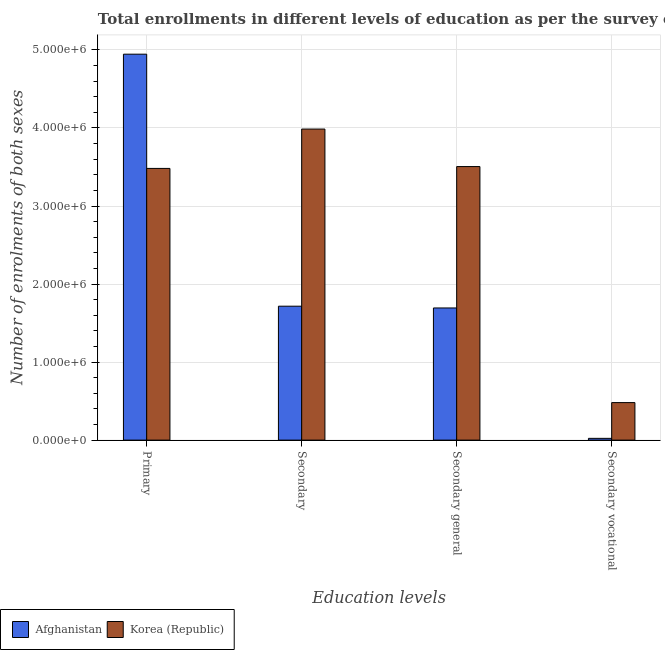How many groups of bars are there?
Offer a very short reply. 4. Are the number of bars per tick equal to the number of legend labels?
Your response must be concise. Yes. How many bars are there on the 4th tick from the left?
Make the answer very short. 2. What is the label of the 2nd group of bars from the left?
Provide a short and direct response. Secondary. What is the number of enrolments in secondary vocational education in Korea (Republic)?
Your answer should be very brief. 4.81e+05. Across all countries, what is the maximum number of enrolments in secondary vocational education?
Ensure brevity in your answer.  4.81e+05. Across all countries, what is the minimum number of enrolments in secondary vocational education?
Keep it short and to the point. 2.27e+04. In which country was the number of enrolments in secondary vocational education minimum?
Provide a short and direct response. Afghanistan. What is the total number of enrolments in secondary general education in the graph?
Ensure brevity in your answer.  5.20e+06. What is the difference between the number of enrolments in secondary education in Korea (Republic) and that in Afghanistan?
Make the answer very short. 2.27e+06. What is the difference between the number of enrolments in secondary general education in Korea (Republic) and the number of enrolments in primary education in Afghanistan?
Give a very brief answer. -1.44e+06. What is the average number of enrolments in primary education per country?
Your answer should be very brief. 4.21e+06. What is the difference between the number of enrolments in primary education and number of enrolments in secondary general education in Korea (Republic)?
Ensure brevity in your answer.  -2.35e+04. What is the ratio of the number of enrolments in secondary education in Korea (Republic) to that in Afghanistan?
Provide a short and direct response. 2.32. Is the number of enrolments in secondary education in Afghanistan less than that in Korea (Republic)?
Your response must be concise. Yes. What is the difference between the highest and the second highest number of enrolments in secondary education?
Provide a succinct answer. 2.27e+06. What is the difference between the highest and the lowest number of enrolments in secondary education?
Your response must be concise. 2.27e+06. What does the 2nd bar from the left in Primary represents?
Make the answer very short. Korea (Republic). Is it the case that in every country, the sum of the number of enrolments in primary education and number of enrolments in secondary education is greater than the number of enrolments in secondary general education?
Make the answer very short. Yes. How many bars are there?
Provide a short and direct response. 8. How many countries are there in the graph?
Your response must be concise. 2. Are the values on the major ticks of Y-axis written in scientific E-notation?
Keep it short and to the point. Yes. What is the title of the graph?
Your answer should be compact. Total enrollments in different levels of education as per the survey of 2009. What is the label or title of the X-axis?
Keep it short and to the point. Education levels. What is the label or title of the Y-axis?
Keep it short and to the point. Number of enrolments of both sexes. What is the Number of enrolments of both sexes of Afghanistan in Primary?
Your answer should be very brief. 4.95e+06. What is the Number of enrolments of both sexes of Korea (Republic) in Primary?
Your answer should be very brief. 3.48e+06. What is the Number of enrolments of both sexes in Afghanistan in Secondary?
Provide a succinct answer. 1.72e+06. What is the Number of enrolments of both sexes in Korea (Republic) in Secondary?
Offer a very short reply. 3.99e+06. What is the Number of enrolments of both sexes of Afghanistan in Secondary general?
Offer a terse response. 1.69e+06. What is the Number of enrolments of both sexes in Korea (Republic) in Secondary general?
Provide a short and direct response. 3.51e+06. What is the Number of enrolments of both sexes of Afghanistan in Secondary vocational?
Make the answer very short. 2.27e+04. What is the Number of enrolments of both sexes in Korea (Republic) in Secondary vocational?
Offer a very short reply. 4.81e+05. Across all Education levels, what is the maximum Number of enrolments of both sexes of Afghanistan?
Give a very brief answer. 4.95e+06. Across all Education levels, what is the maximum Number of enrolments of both sexes of Korea (Republic)?
Offer a terse response. 3.99e+06. Across all Education levels, what is the minimum Number of enrolments of both sexes of Afghanistan?
Make the answer very short. 2.27e+04. Across all Education levels, what is the minimum Number of enrolments of both sexes in Korea (Republic)?
Your response must be concise. 4.81e+05. What is the total Number of enrolments of both sexes in Afghanistan in the graph?
Your answer should be compact. 8.38e+06. What is the total Number of enrolments of both sexes in Korea (Republic) in the graph?
Offer a very short reply. 1.15e+07. What is the difference between the Number of enrolments of both sexes in Afghanistan in Primary and that in Secondary?
Offer a very short reply. 3.23e+06. What is the difference between the Number of enrolments of both sexes in Korea (Republic) in Primary and that in Secondary?
Your response must be concise. -5.04e+05. What is the difference between the Number of enrolments of both sexes in Afghanistan in Primary and that in Secondary general?
Provide a short and direct response. 3.25e+06. What is the difference between the Number of enrolments of both sexes in Korea (Republic) in Primary and that in Secondary general?
Provide a short and direct response. -2.35e+04. What is the difference between the Number of enrolments of both sexes in Afghanistan in Primary and that in Secondary vocational?
Keep it short and to the point. 4.92e+06. What is the difference between the Number of enrolments of both sexes of Korea (Republic) in Primary and that in Secondary vocational?
Offer a very short reply. 3.00e+06. What is the difference between the Number of enrolments of both sexes of Afghanistan in Secondary and that in Secondary general?
Your response must be concise. 2.27e+04. What is the difference between the Number of enrolments of both sexes of Korea (Republic) in Secondary and that in Secondary general?
Keep it short and to the point. 4.81e+05. What is the difference between the Number of enrolments of both sexes in Afghanistan in Secondary and that in Secondary vocational?
Your answer should be very brief. 1.69e+06. What is the difference between the Number of enrolments of both sexes of Korea (Republic) in Secondary and that in Secondary vocational?
Offer a very short reply. 3.51e+06. What is the difference between the Number of enrolments of both sexes of Afghanistan in Secondary general and that in Secondary vocational?
Provide a short and direct response. 1.67e+06. What is the difference between the Number of enrolments of both sexes in Korea (Republic) in Secondary general and that in Secondary vocational?
Keep it short and to the point. 3.02e+06. What is the difference between the Number of enrolments of both sexes in Afghanistan in Primary and the Number of enrolments of both sexes in Korea (Republic) in Secondary?
Your response must be concise. 9.60e+05. What is the difference between the Number of enrolments of both sexes of Afghanistan in Primary and the Number of enrolments of both sexes of Korea (Republic) in Secondary general?
Give a very brief answer. 1.44e+06. What is the difference between the Number of enrolments of both sexes in Afghanistan in Primary and the Number of enrolments of both sexes in Korea (Republic) in Secondary vocational?
Provide a short and direct response. 4.46e+06. What is the difference between the Number of enrolments of both sexes in Afghanistan in Secondary and the Number of enrolments of both sexes in Korea (Republic) in Secondary general?
Keep it short and to the point. -1.79e+06. What is the difference between the Number of enrolments of both sexes in Afghanistan in Secondary and the Number of enrolments of both sexes in Korea (Republic) in Secondary vocational?
Offer a very short reply. 1.24e+06. What is the difference between the Number of enrolments of both sexes in Afghanistan in Secondary general and the Number of enrolments of both sexes in Korea (Republic) in Secondary vocational?
Provide a short and direct response. 1.21e+06. What is the average Number of enrolments of both sexes of Afghanistan per Education levels?
Provide a succinct answer. 2.09e+06. What is the average Number of enrolments of both sexes of Korea (Republic) per Education levels?
Provide a short and direct response. 2.86e+06. What is the difference between the Number of enrolments of both sexes in Afghanistan and Number of enrolments of both sexes in Korea (Republic) in Primary?
Offer a terse response. 1.46e+06. What is the difference between the Number of enrolments of both sexes of Afghanistan and Number of enrolments of both sexes of Korea (Republic) in Secondary?
Offer a terse response. -2.27e+06. What is the difference between the Number of enrolments of both sexes of Afghanistan and Number of enrolments of both sexes of Korea (Republic) in Secondary general?
Make the answer very short. -1.81e+06. What is the difference between the Number of enrolments of both sexes in Afghanistan and Number of enrolments of both sexes in Korea (Republic) in Secondary vocational?
Your response must be concise. -4.58e+05. What is the ratio of the Number of enrolments of both sexes in Afghanistan in Primary to that in Secondary?
Your response must be concise. 2.88. What is the ratio of the Number of enrolments of both sexes in Korea (Republic) in Primary to that in Secondary?
Ensure brevity in your answer.  0.87. What is the ratio of the Number of enrolments of both sexes of Afghanistan in Primary to that in Secondary general?
Give a very brief answer. 2.92. What is the ratio of the Number of enrolments of both sexes in Korea (Republic) in Primary to that in Secondary general?
Offer a terse response. 0.99. What is the ratio of the Number of enrolments of both sexes of Afghanistan in Primary to that in Secondary vocational?
Give a very brief answer. 217.76. What is the ratio of the Number of enrolments of both sexes of Korea (Republic) in Primary to that in Secondary vocational?
Keep it short and to the point. 7.24. What is the ratio of the Number of enrolments of both sexes of Afghanistan in Secondary to that in Secondary general?
Your answer should be compact. 1.01. What is the ratio of the Number of enrolments of both sexes in Korea (Republic) in Secondary to that in Secondary general?
Your answer should be very brief. 1.14. What is the ratio of the Number of enrolments of both sexes of Afghanistan in Secondary to that in Secondary vocational?
Your answer should be very brief. 75.57. What is the ratio of the Number of enrolments of both sexes of Korea (Republic) in Secondary to that in Secondary vocational?
Your answer should be very brief. 8.29. What is the ratio of the Number of enrolments of both sexes of Afghanistan in Secondary general to that in Secondary vocational?
Your answer should be very brief. 74.57. What is the ratio of the Number of enrolments of both sexes in Korea (Republic) in Secondary general to that in Secondary vocational?
Offer a very short reply. 7.29. What is the difference between the highest and the second highest Number of enrolments of both sexes in Afghanistan?
Ensure brevity in your answer.  3.23e+06. What is the difference between the highest and the second highest Number of enrolments of both sexes of Korea (Republic)?
Make the answer very short. 4.81e+05. What is the difference between the highest and the lowest Number of enrolments of both sexes in Afghanistan?
Keep it short and to the point. 4.92e+06. What is the difference between the highest and the lowest Number of enrolments of both sexes of Korea (Republic)?
Keep it short and to the point. 3.51e+06. 